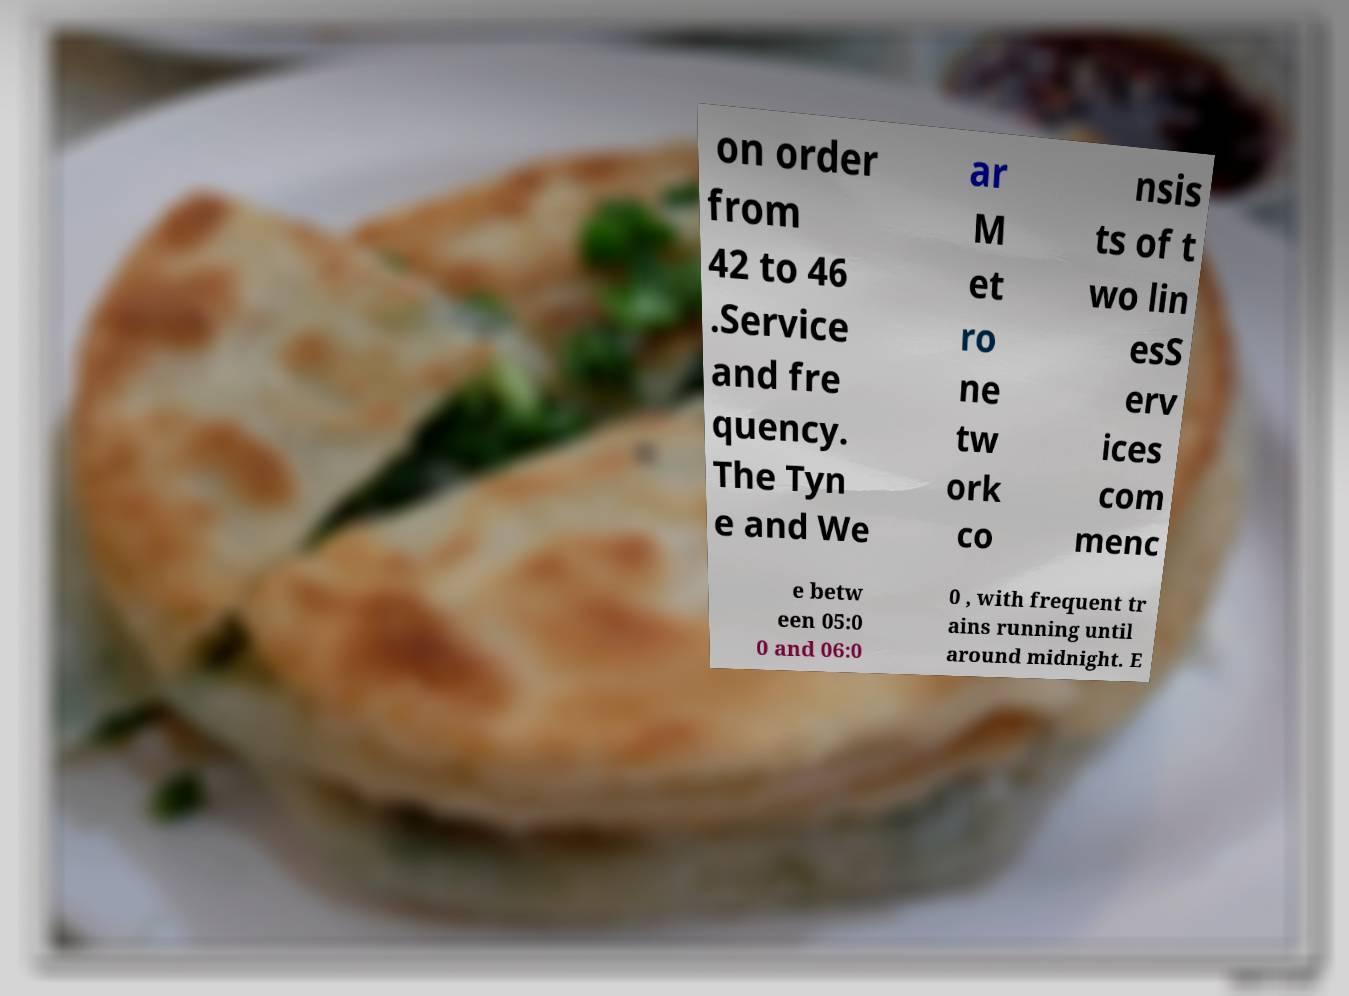There's text embedded in this image that I need extracted. Can you transcribe it verbatim? on order from 42 to 46 .Service and fre quency. The Tyn e and We ar M et ro ne tw ork co nsis ts of t wo lin esS erv ices com menc e betw een 05:0 0 and 06:0 0 , with frequent tr ains running until around midnight. E 